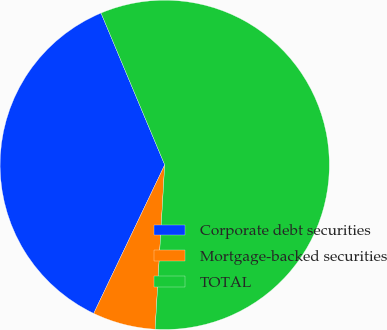Convert chart. <chart><loc_0><loc_0><loc_500><loc_500><pie_chart><fcel>Corporate debt securities<fcel>Mortgage-backed securities<fcel>TOTAL<nl><fcel>36.58%<fcel>6.17%<fcel>57.25%<nl></chart> 